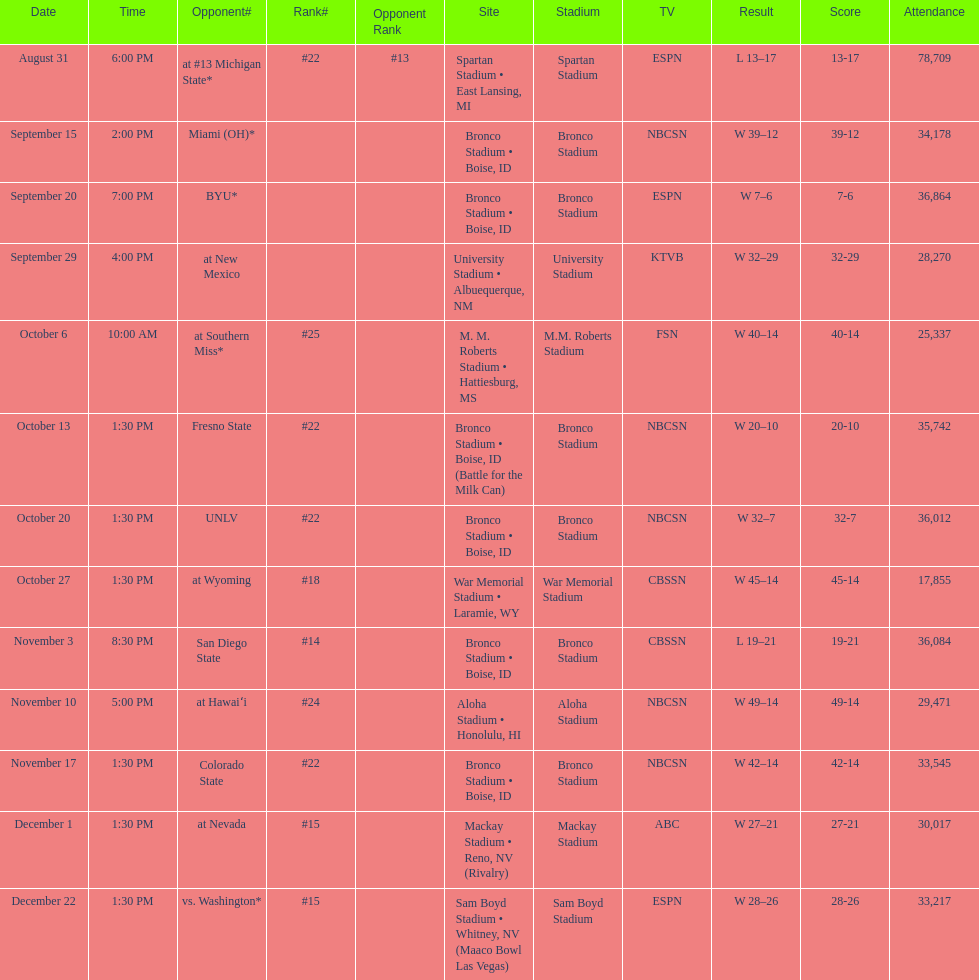Did the broncos on september 29th win by less than 5 points? Yes. 